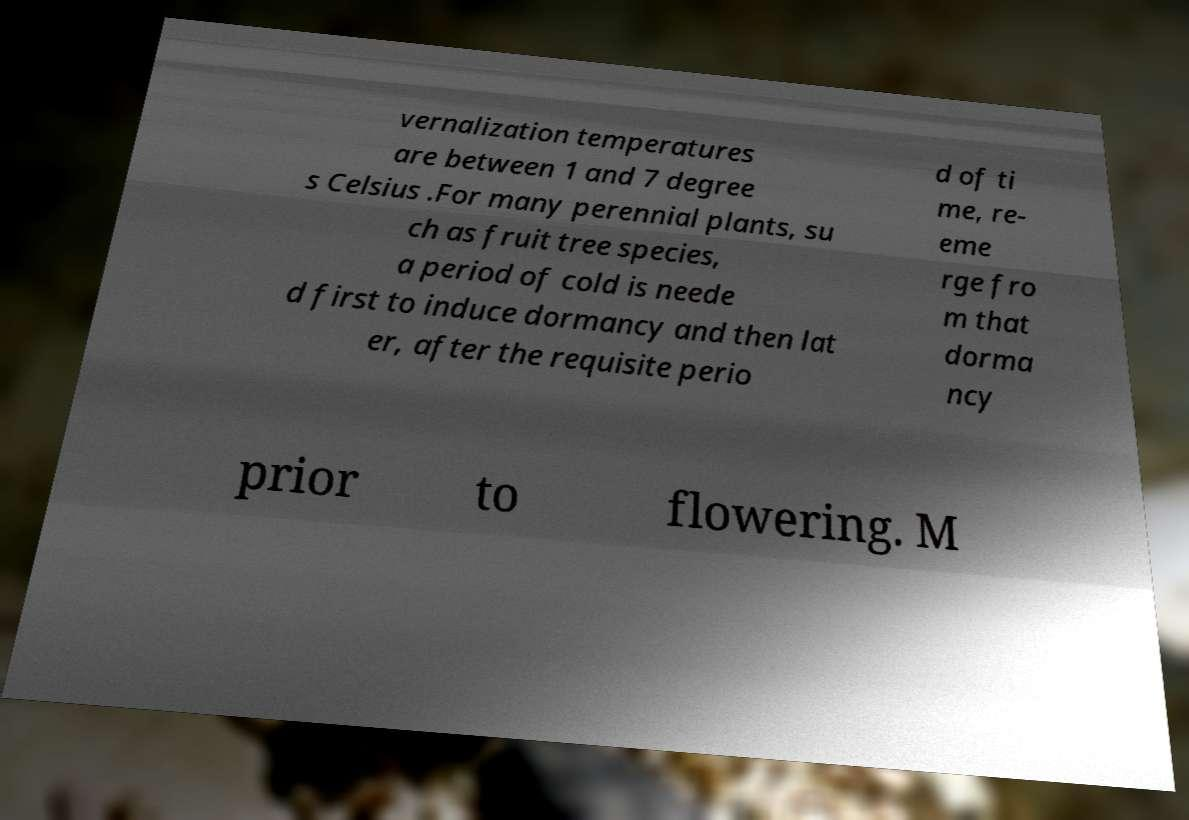What messages or text are displayed in this image? I need them in a readable, typed format. vernalization temperatures are between 1 and 7 degree s Celsius .For many perennial plants, su ch as fruit tree species, a period of cold is neede d first to induce dormancy and then lat er, after the requisite perio d of ti me, re- eme rge fro m that dorma ncy prior to flowering. M 